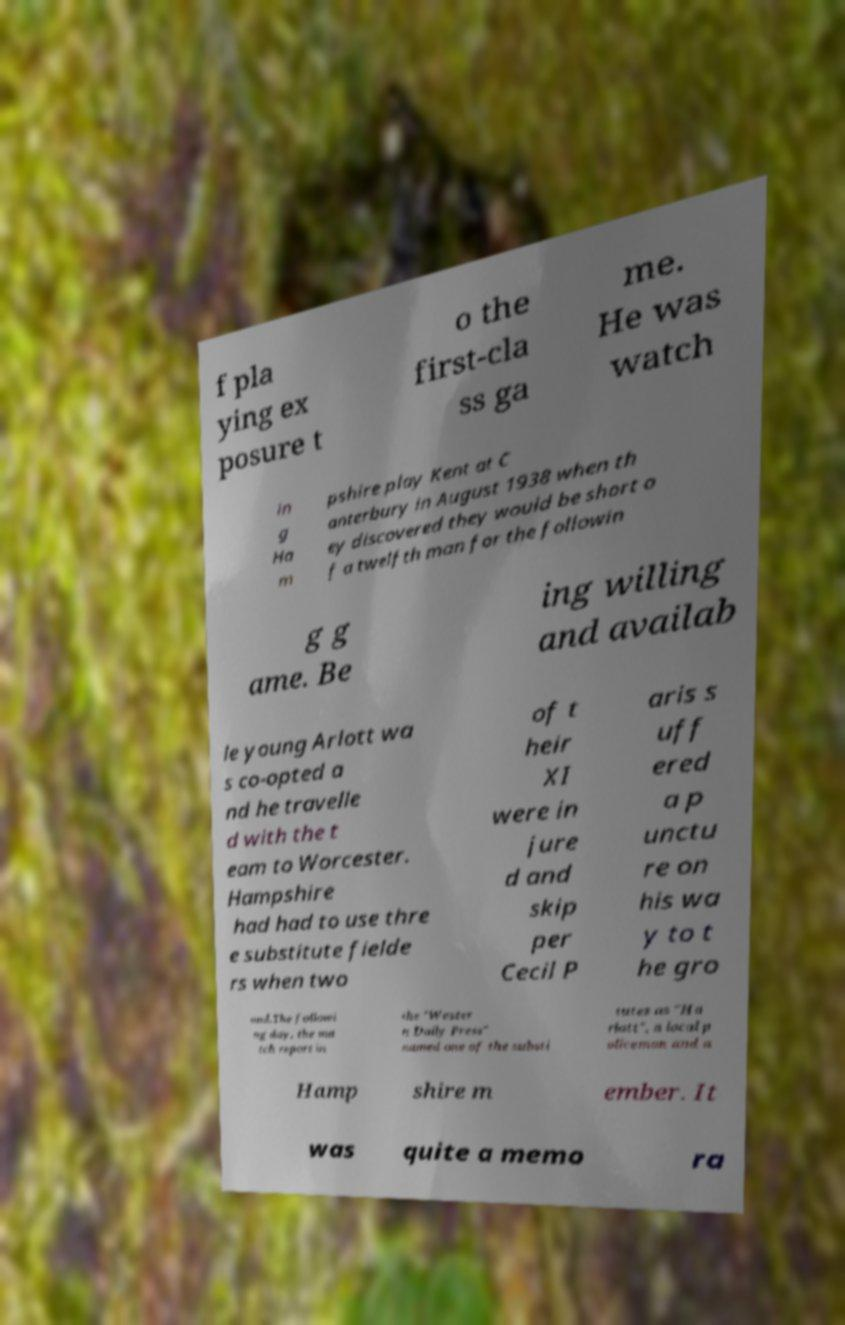I need the written content from this picture converted into text. Can you do that? f pla ying ex posure t o the first-cla ss ga me. He was watch in g Ha m pshire play Kent at C anterbury in August 1938 when th ey discovered they would be short o f a twelfth man for the followin g g ame. Be ing willing and availab le young Arlott wa s co-opted a nd he travelle d with the t eam to Worcester. Hampshire had had to use thre e substitute fielde rs when two of t heir XI were in jure d and skip per Cecil P aris s uff ered a p unctu re on his wa y to t he gro und.The followi ng day, the ma tch report in the "Wester n Daily Press" named one of the substi tutes as "Ha rlott", a local p oliceman and a Hamp shire m ember. It was quite a memo ra 